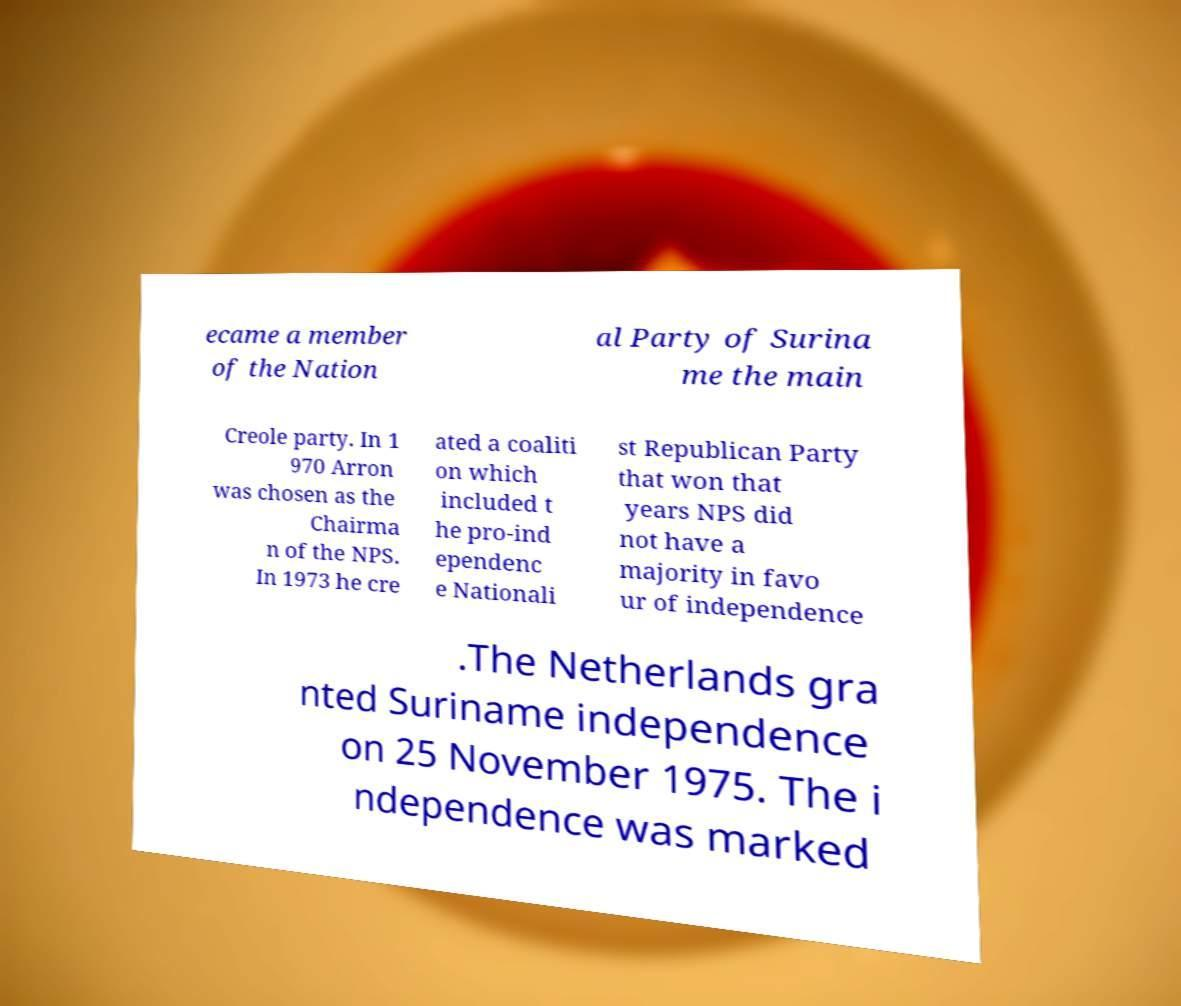There's text embedded in this image that I need extracted. Can you transcribe it verbatim? ecame a member of the Nation al Party of Surina me the main Creole party. In 1 970 Arron was chosen as the Chairma n of the NPS. In 1973 he cre ated a coaliti on which included t he pro-ind ependenc e Nationali st Republican Party that won that years NPS did not have a majority in favo ur of independence .The Netherlands gra nted Suriname independence on 25 November 1975. The i ndependence was marked 